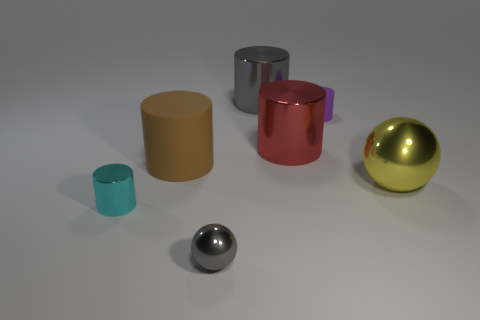Subtract all small cyan cylinders. How many cylinders are left? 4 Add 3 brown cylinders. How many objects exist? 10 Subtract all yellow balls. How many balls are left? 1 Subtract 3 cylinders. How many cylinders are left? 2 Subtract all balls. How many objects are left? 5 Subtract all yellow cylinders. Subtract all gray spheres. How many cylinders are left? 5 Subtract all gray metallic cylinders. Subtract all purple objects. How many objects are left? 5 Add 4 large shiny cylinders. How many large shiny cylinders are left? 6 Add 5 large gray metallic things. How many large gray metallic things exist? 6 Subtract 0 brown balls. How many objects are left? 7 